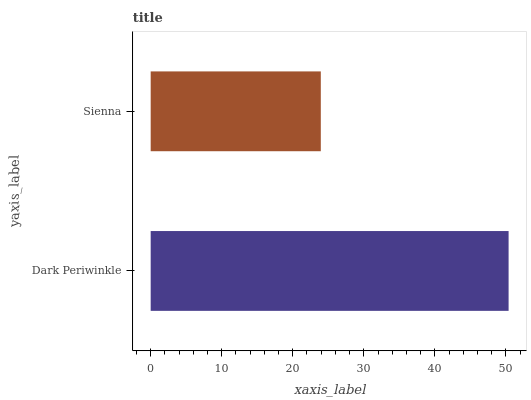Is Sienna the minimum?
Answer yes or no. Yes. Is Dark Periwinkle the maximum?
Answer yes or no. Yes. Is Sienna the maximum?
Answer yes or no. No. Is Dark Periwinkle greater than Sienna?
Answer yes or no. Yes. Is Sienna less than Dark Periwinkle?
Answer yes or no. Yes. Is Sienna greater than Dark Periwinkle?
Answer yes or no. No. Is Dark Periwinkle less than Sienna?
Answer yes or no. No. Is Dark Periwinkle the high median?
Answer yes or no. Yes. Is Sienna the low median?
Answer yes or no. Yes. Is Sienna the high median?
Answer yes or no. No. Is Dark Periwinkle the low median?
Answer yes or no. No. 